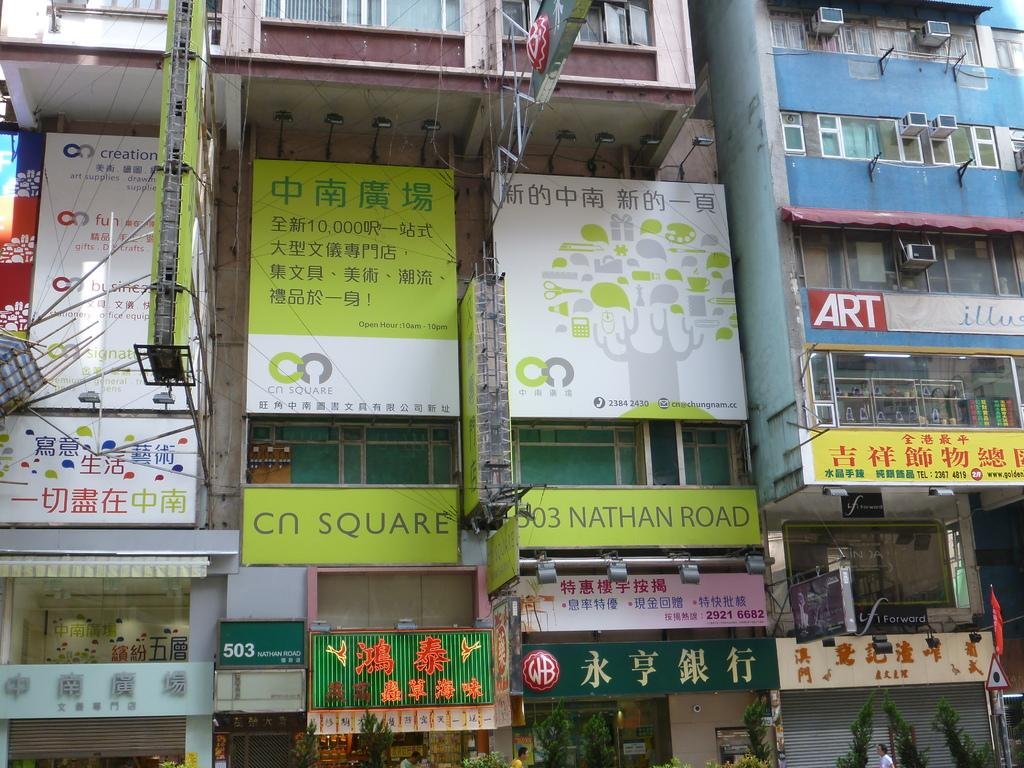Provide a one-sentence caption for the provided image. City buildings are covered with advertisement signs, in the midst of which is a sign that says 303 Nathan Road. 